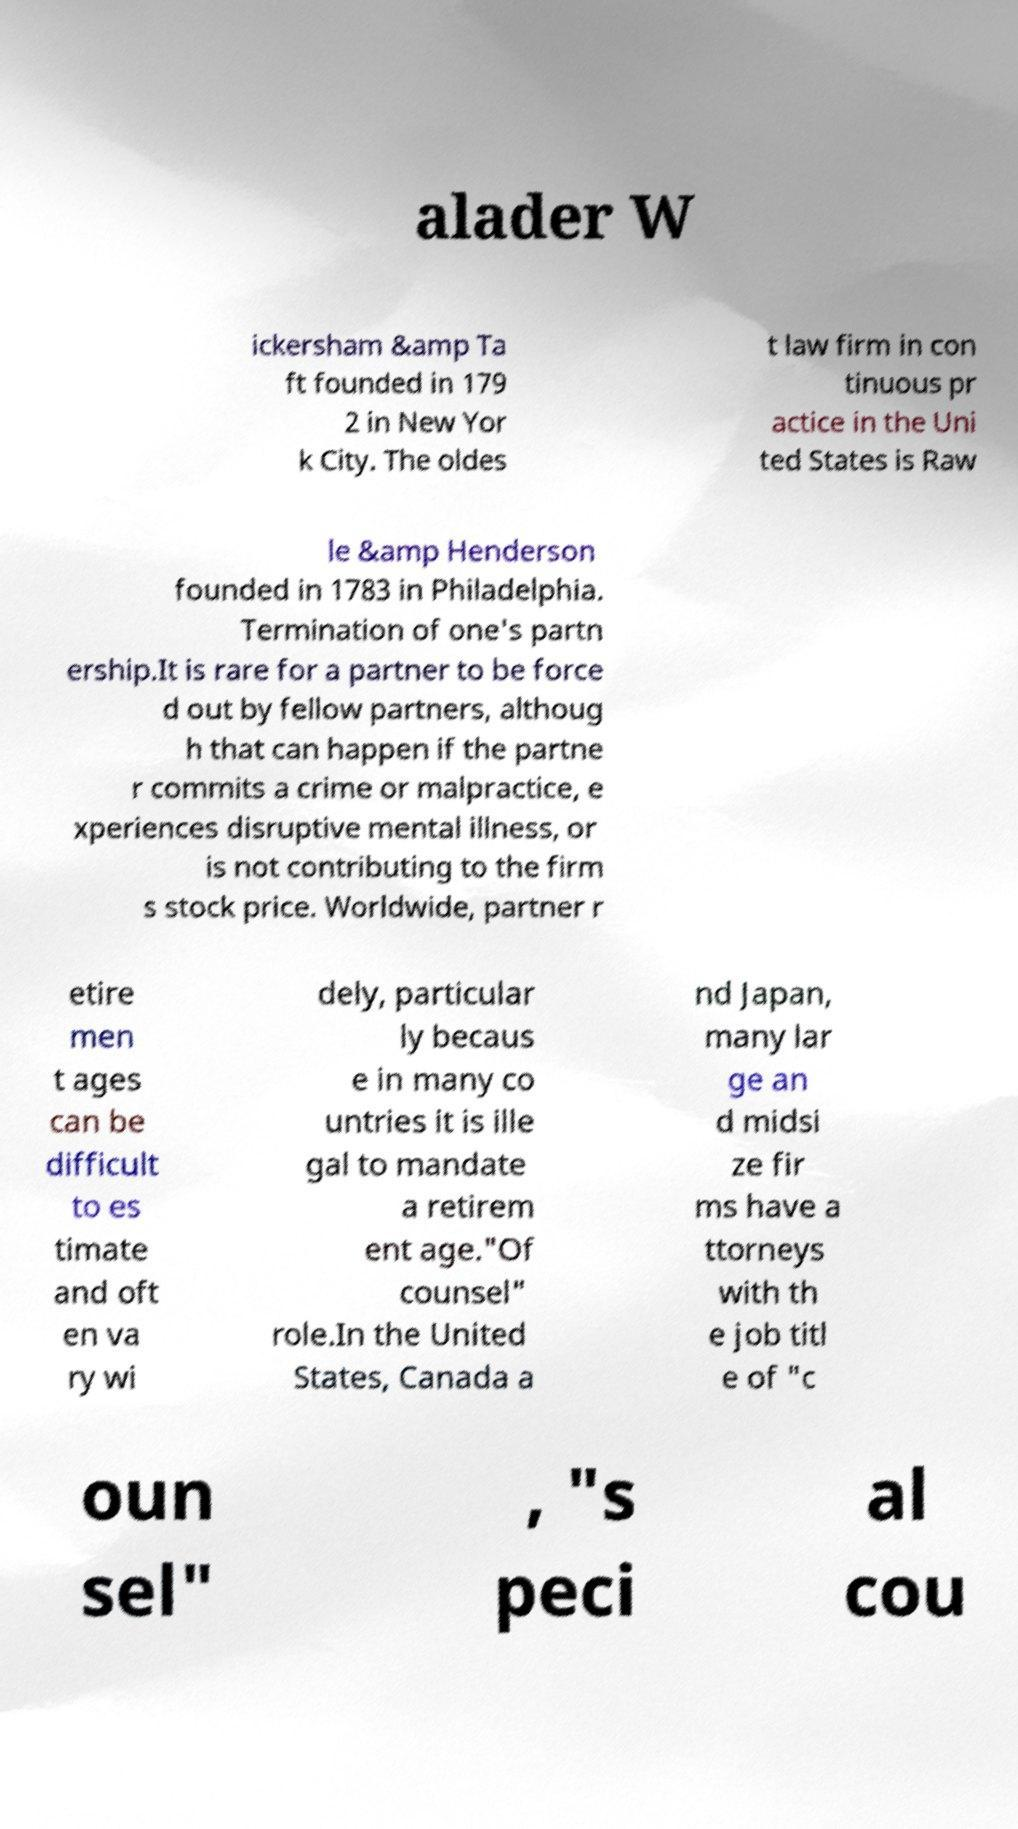Could you extract and type out the text from this image? alader W ickersham &amp Ta ft founded in 179 2 in New Yor k City. The oldes t law firm in con tinuous pr actice in the Uni ted States is Raw le &amp Henderson founded in 1783 in Philadelphia. Termination of one's partn ership.It is rare for a partner to be force d out by fellow partners, althoug h that can happen if the partne r commits a crime or malpractice, e xperiences disruptive mental illness, or is not contributing to the firm s stock price. Worldwide, partner r etire men t ages can be difficult to es timate and oft en va ry wi dely, particular ly becaus e in many co untries it is ille gal to mandate a retirem ent age."Of counsel" role.In the United States, Canada a nd Japan, many lar ge an d midsi ze fir ms have a ttorneys with th e job titl e of "c oun sel" , "s peci al cou 